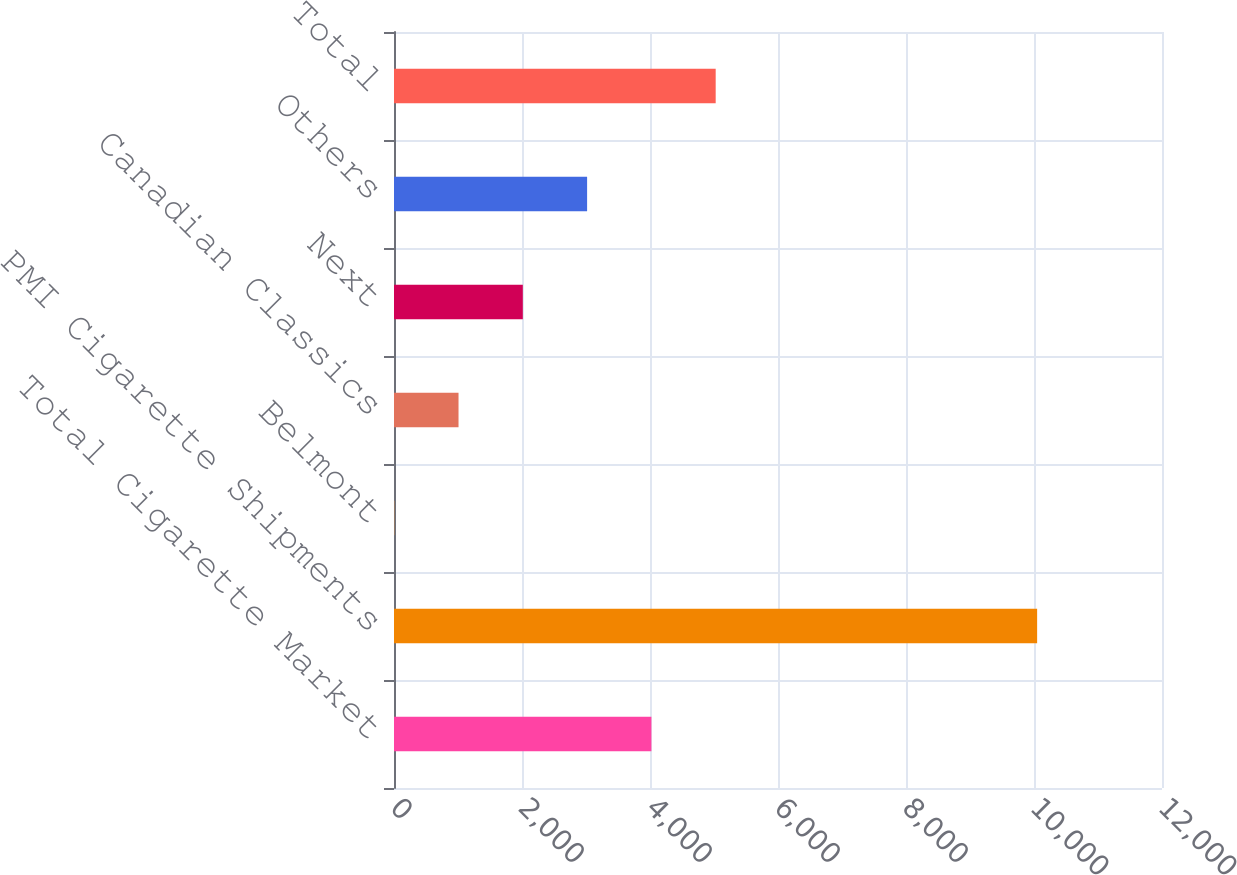<chart> <loc_0><loc_0><loc_500><loc_500><bar_chart><fcel>Total Cigarette Market<fcel>PMI Cigarette Shipments<fcel>Belmont<fcel>Canadian Classics<fcel>Next<fcel>Others<fcel>Total<nl><fcel>4021.82<fcel>10049<fcel>3.7<fcel>1008.23<fcel>2012.76<fcel>3017.29<fcel>5026.35<nl></chart> 